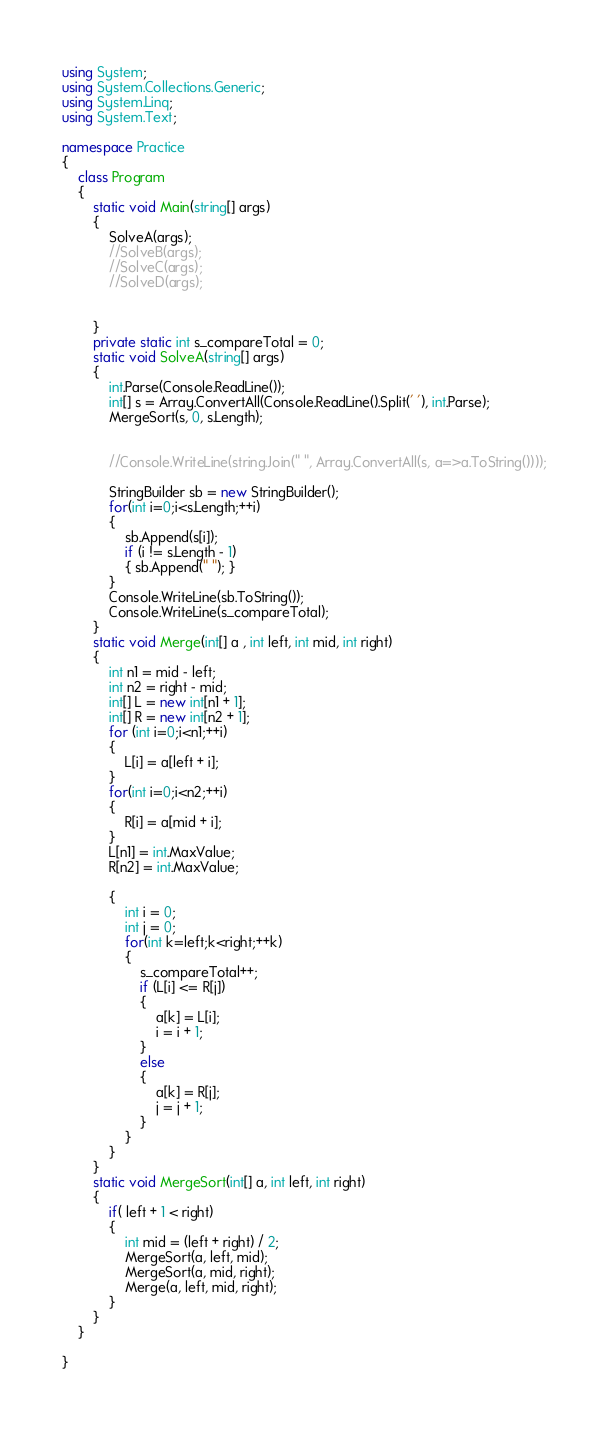Convert code to text. <code><loc_0><loc_0><loc_500><loc_500><_C#_>using System;
using System.Collections.Generic;
using System.Linq;
using System.Text;

namespace Practice
{
    class Program
    {
        static void Main(string[] args)
        {
            SolveA(args);
            //SolveB(args);
            //SolveC(args);
            //SolveD(args);


        }
        private static int s_compareTotal = 0;
        static void SolveA(string[] args)
        {
            int.Parse(Console.ReadLine());
            int[] s = Array.ConvertAll(Console.ReadLine().Split(' '), int.Parse);
            MergeSort(s, 0, s.Length);


            //Console.WriteLine(string.Join(" ", Array.ConvertAll(s, a=>a.ToString())));

            StringBuilder sb = new StringBuilder();
            for(int i=0;i<s.Length;++i)
            {
                sb.Append(s[i]);
                if (i != s.Length - 1)
                { sb.Append(" "); }
            }
            Console.WriteLine(sb.ToString());
            Console.WriteLine(s_compareTotal);
        }
        static void Merge(int[] a , int left, int mid, int right)
        {
            int n1 = mid - left;
            int n2 = right - mid;
            int[] L = new int[n1 + 1];
            int[] R = new int[n2 + 1];
            for (int i=0;i<n1;++i)
            {
                L[i] = a[left + i];
            }
            for(int i=0;i<n2;++i)
            {
                R[i] = a[mid + i];
            }
            L[n1] = int.MaxValue;
            R[n2] = int.MaxValue;

            {
                int i = 0;
                int j = 0;
                for(int k=left;k<right;++k)
                {
                    s_compareTotal++;
                    if (L[i] <= R[j])
                    {
                        a[k] = L[i];
                        i = i + 1;
                    }
                    else
                    {
                        a[k] = R[j];
                        j = j + 1;
                    }
                }
            }
        }
        static void MergeSort(int[] a, int left, int right)
        {
            if( left + 1 < right)
            {
                int mid = (left + right) / 2;
                MergeSort(a, left, mid);
                MergeSort(a, mid, right);
                Merge(a, left, mid, right);
            }
        }
    }

}

</code> 